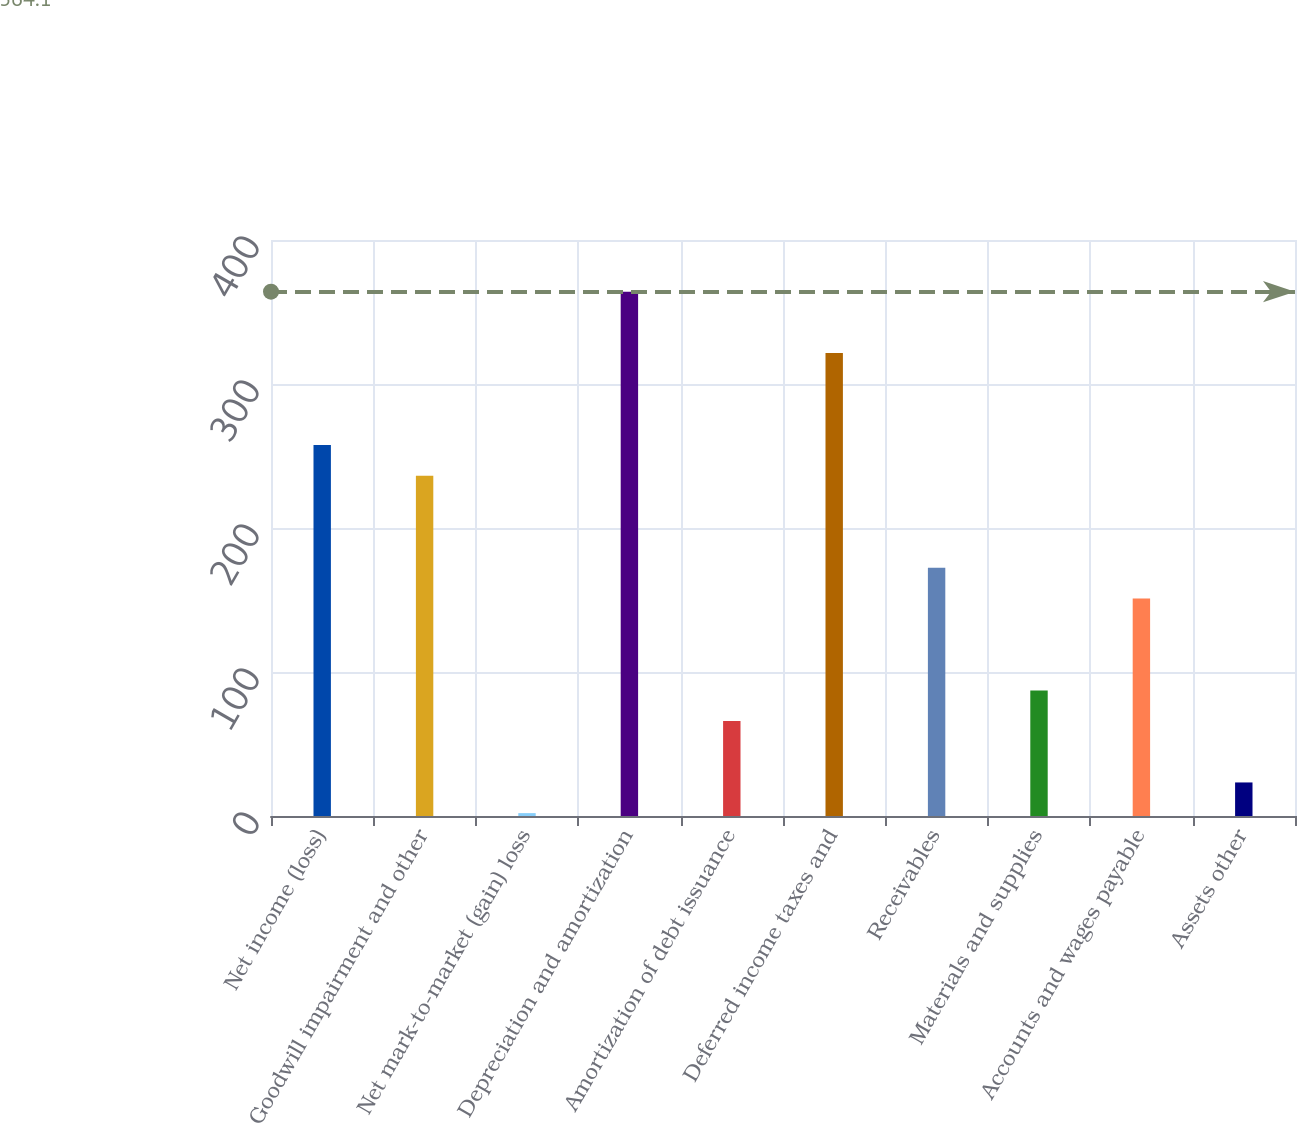Convert chart to OTSL. <chart><loc_0><loc_0><loc_500><loc_500><bar_chart><fcel>Net income (loss)<fcel>Goodwill impairment and other<fcel>Net mark-to-market (gain) loss<fcel>Depreciation and amortization<fcel>Amortization of debt issuance<fcel>Deferred income taxes and<fcel>Receivables<fcel>Materials and supplies<fcel>Accounts and wages payable<fcel>Assets other<nl><fcel>257.6<fcel>236.3<fcel>2<fcel>364.1<fcel>65.9<fcel>321.5<fcel>172.4<fcel>87.2<fcel>151.1<fcel>23.3<nl></chart> 